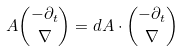Convert formula to latex. <formula><loc_0><loc_0><loc_500><loc_500>A { - \partial _ { t } \choose \nabla } = d A \cdot { - \partial _ { t } \choose \nabla }</formula> 